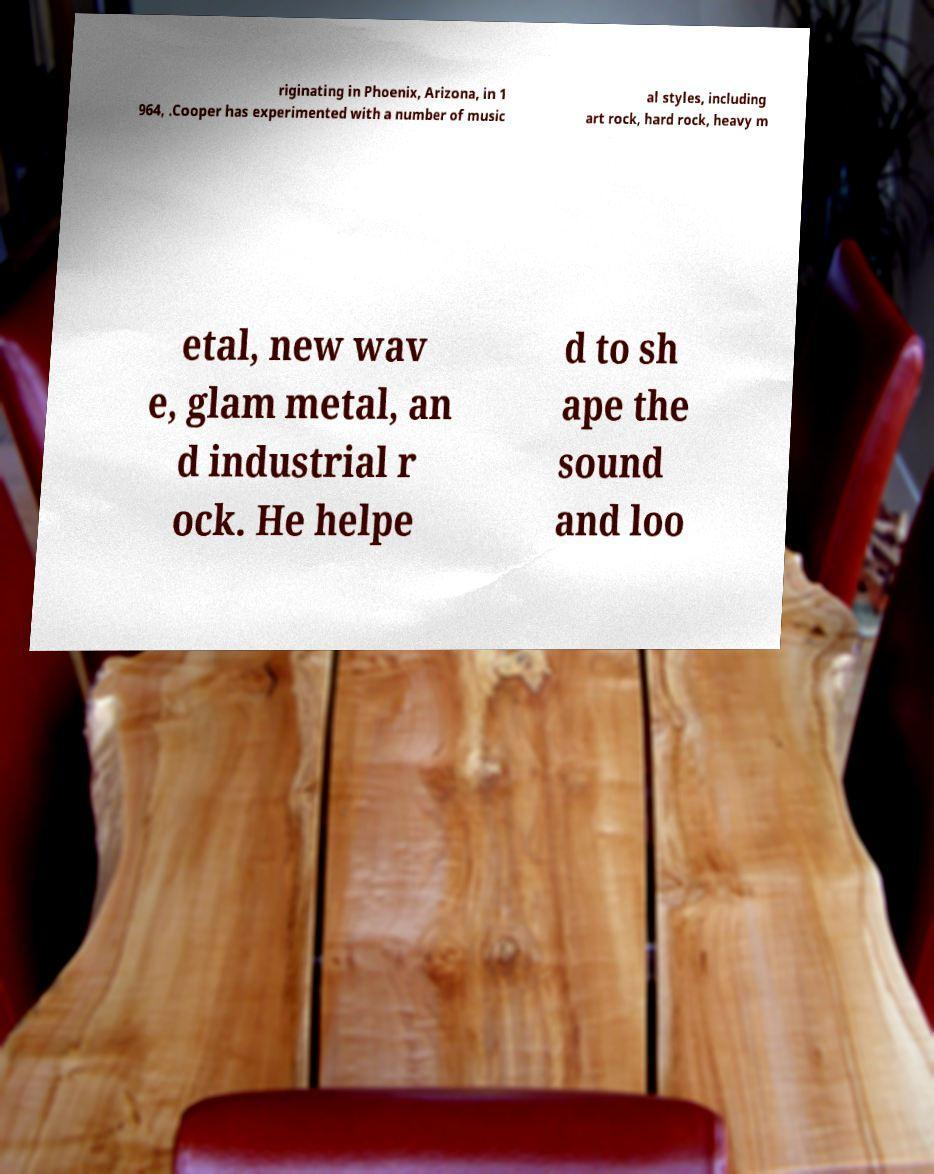There's text embedded in this image that I need extracted. Can you transcribe it verbatim? riginating in Phoenix, Arizona, in 1 964, .Cooper has experimented with a number of music al styles, including art rock, hard rock, heavy m etal, new wav e, glam metal, an d industrial r ock. He helpe d to sh ape the sound and loo 